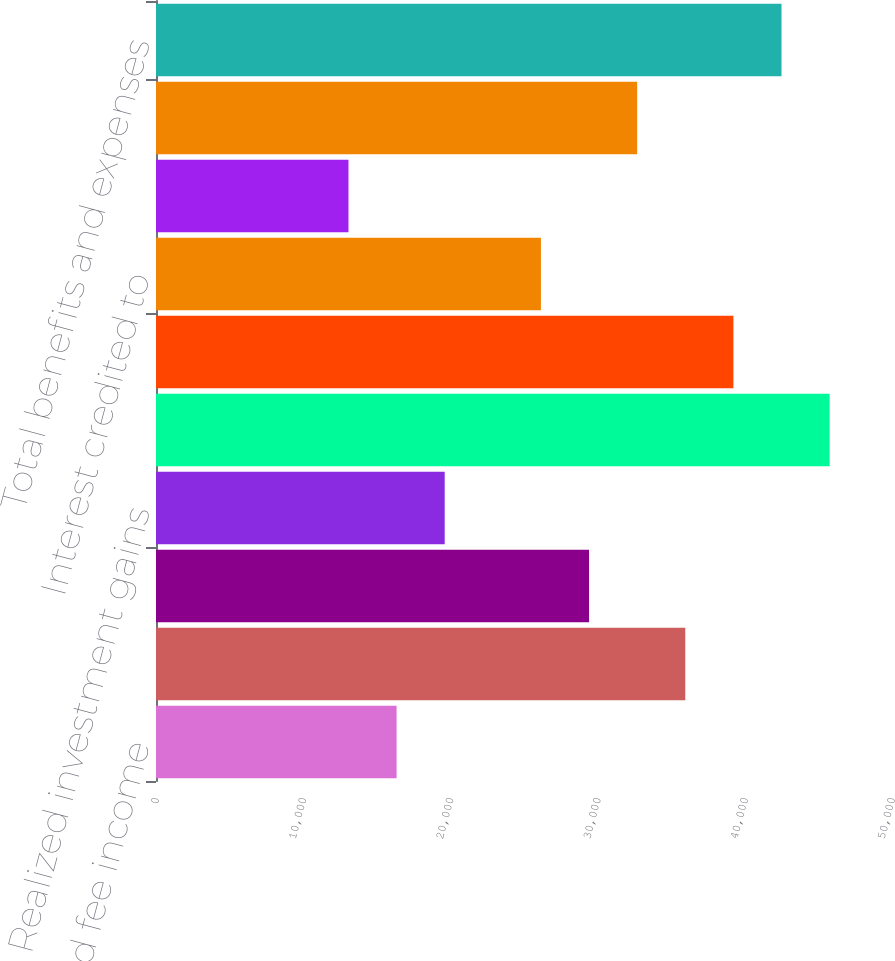Convert chart to OTSL. <chart><loc_0><loc_0><loc_500><loc_500><bar_chart><fcel>Policy charges and fee income<fcel>Net investment income<fcel>Asset management fees and<fcel>Realized investment gains<fcel>Total revenues<fcel>Policyholders' benefits<fcel>Interest credited to<fcel>Dividends to policyholders<fcel>General and administrative<fcel>Total benefits and expenses<nl><fcel>16344.4<fcel>35956.7<fcel>29419.3<fcel>19613.1<fcel>45762.9<fcel>39225.5<fcel>26150.5<fcel>13075.6<fcel>32688<fcel>42494.2<nl></chart> 